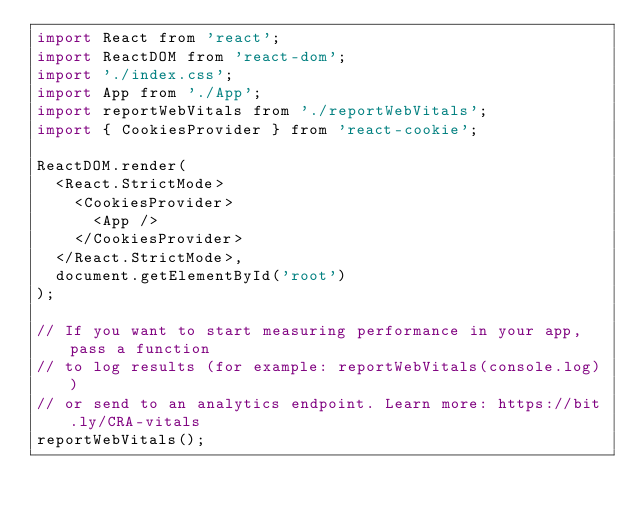<code> <loc_0><loc_0><loc_500><loc_500><_JavaScript_>import React from 'react';
import ReactDOM from 'react-dom';
import './index.css';
import App from './App';
import reportWebVitals from './reportWebVitals';
import { CookiesProvider } from 'react-cookie';

ReactDOM.render(
  <React.StrictMode>
    <CookiesProvider>
      <App />
    </CookiesProvider>
  </React.StrictMode>,
  document.getElementById('root')
);

// If you want to start measuring performance in your app, pass a function
// to log results (for example: reportWebVitals(console.log))
// or send to an analytics endpoint. Learn more: https://bit.ly/CRA-vitals
reportWebVitals();
</code> 